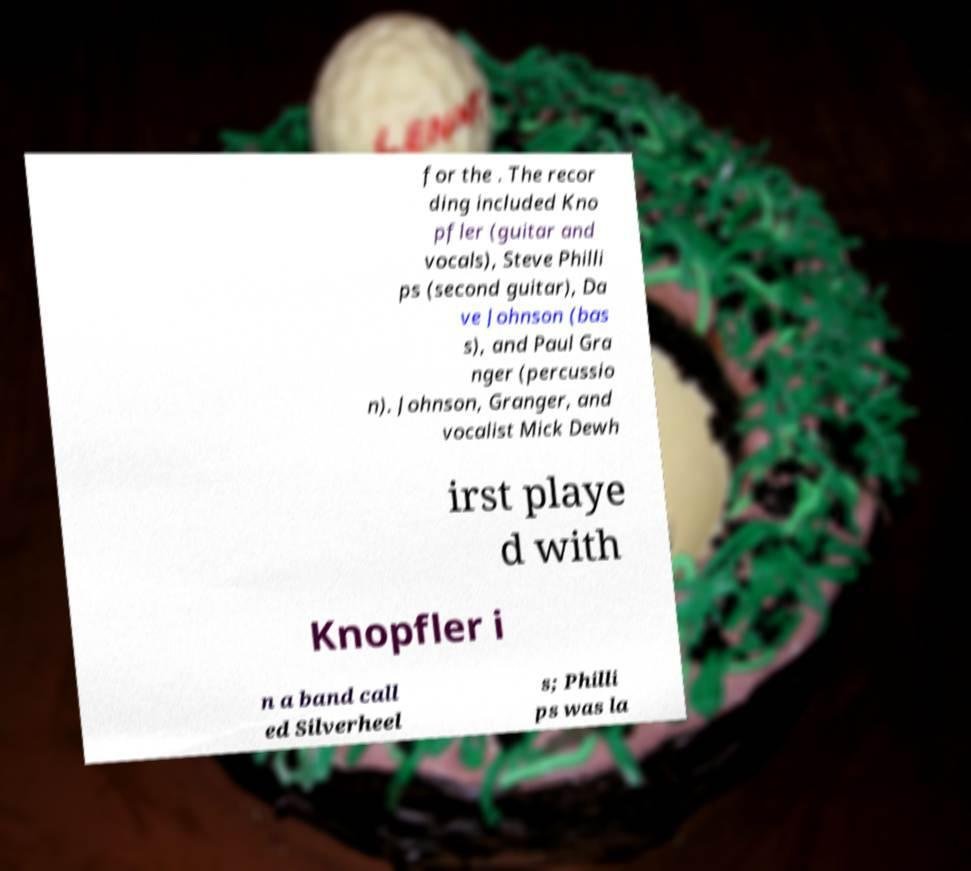Could you extract and type out the text from this image? for the . The recor ding included Kno pfler (guitar and vocals), Steve Philli ps (second guitar), Da ve Johnson (bas s), and Paul Gra nger (percussio n). Johnson, Granger, and vocalist Mick Dewh irst playe d with Knopfler i n a band call ed Silverheel s; Philli ps was la 